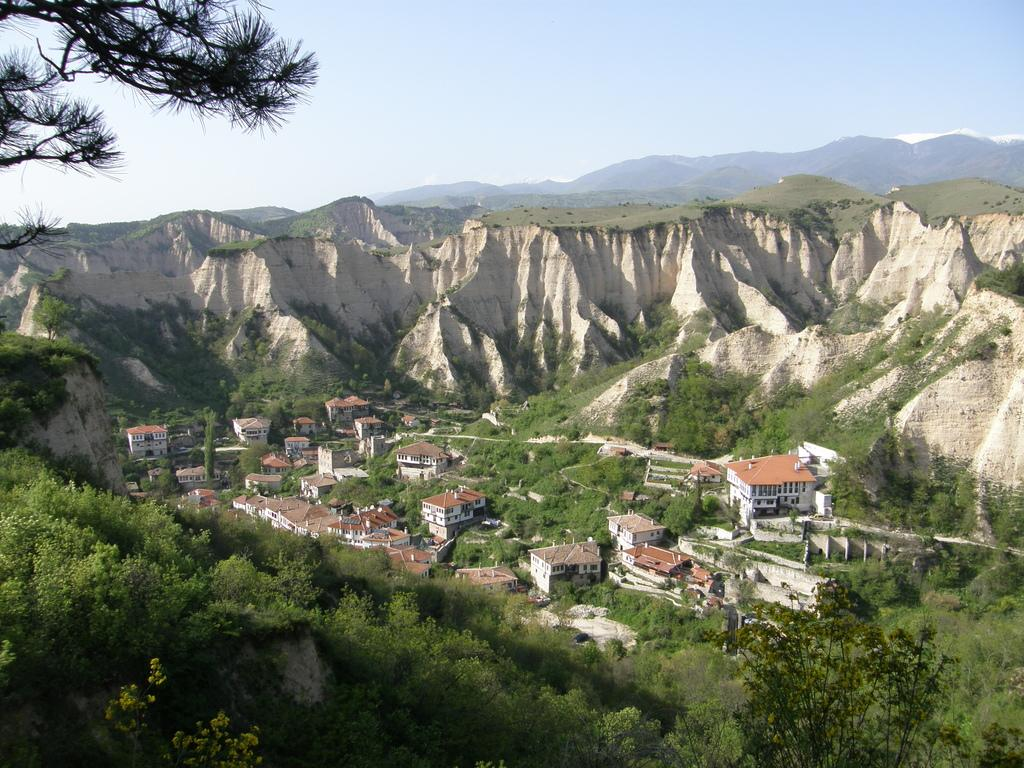What type of natural elements can be seen in the image? There are trees in the image. What type of man-made structures are present in the image? There are buildings in the image. What type of geographical feature can be seen in the image? There are mountains in the image. What is visible in the background of the image? The sky is visible in the image. What type of hospital can be seen in the image? There is no hospital present in the image. What activity are the geese participating in within the image? There are no geese present in the image, so no activity can be observed. 